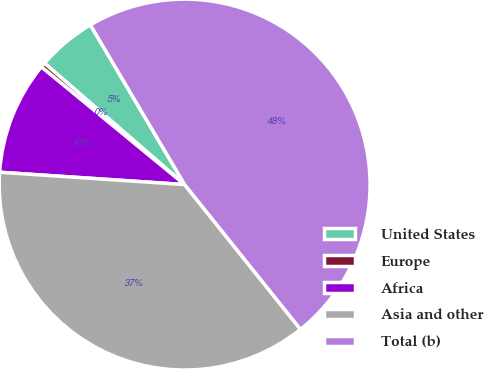Convert chart to OTSL. <chart><loc_0><loc_0><loc_500><loc_500><pie_chart><fcel>United States<fcel>Europe<fcel>Africa<fcel>Asia and other<fcel>Total (b)<nl><fcel>5.15%<fcel>0.42%<fcel>9.88%<fcel>36.8%<fcel>47.74%<nl></chart> 